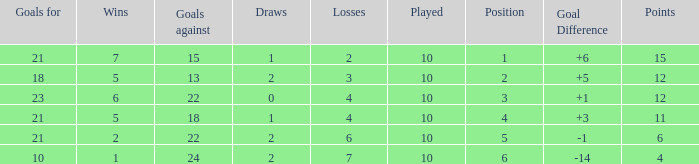Can you tell me the lowest Played that has the Position larger than 2, and the Draws smaller than 2, and the Goals against smaller than 18? None. 